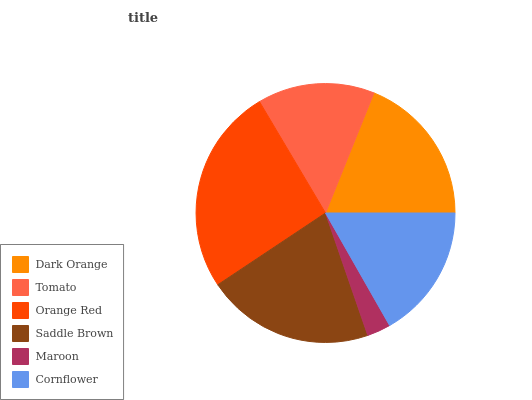Is Maroon the minimum?
Answer yes or no. Yes. Is Orange Red the maximum?
Answer yes or no. Yes. Is Tomato the minimum?
Answer yes or no. No. Is Tomato the maximum?
Answer yes or no. No. Is Dark Orange greater than Tomato?
Answer yes or no. Yes. Is Tomato less than Dark Orange?
Answer yes or no. Yes. Is Tomato greater than Dark Orange?
Answer yes or no. No. Is Dark Orange less than Tomato?
Answer yes or no. No. Is Dark Orange the high median?
Answer yes or no. Yes. Is Cornflower the low median?
Answer yes or no. Yes. Is Tomato the high median?
Answer yes or no. No. Is Dark Orange the low median?
Answer yes or no. No. 